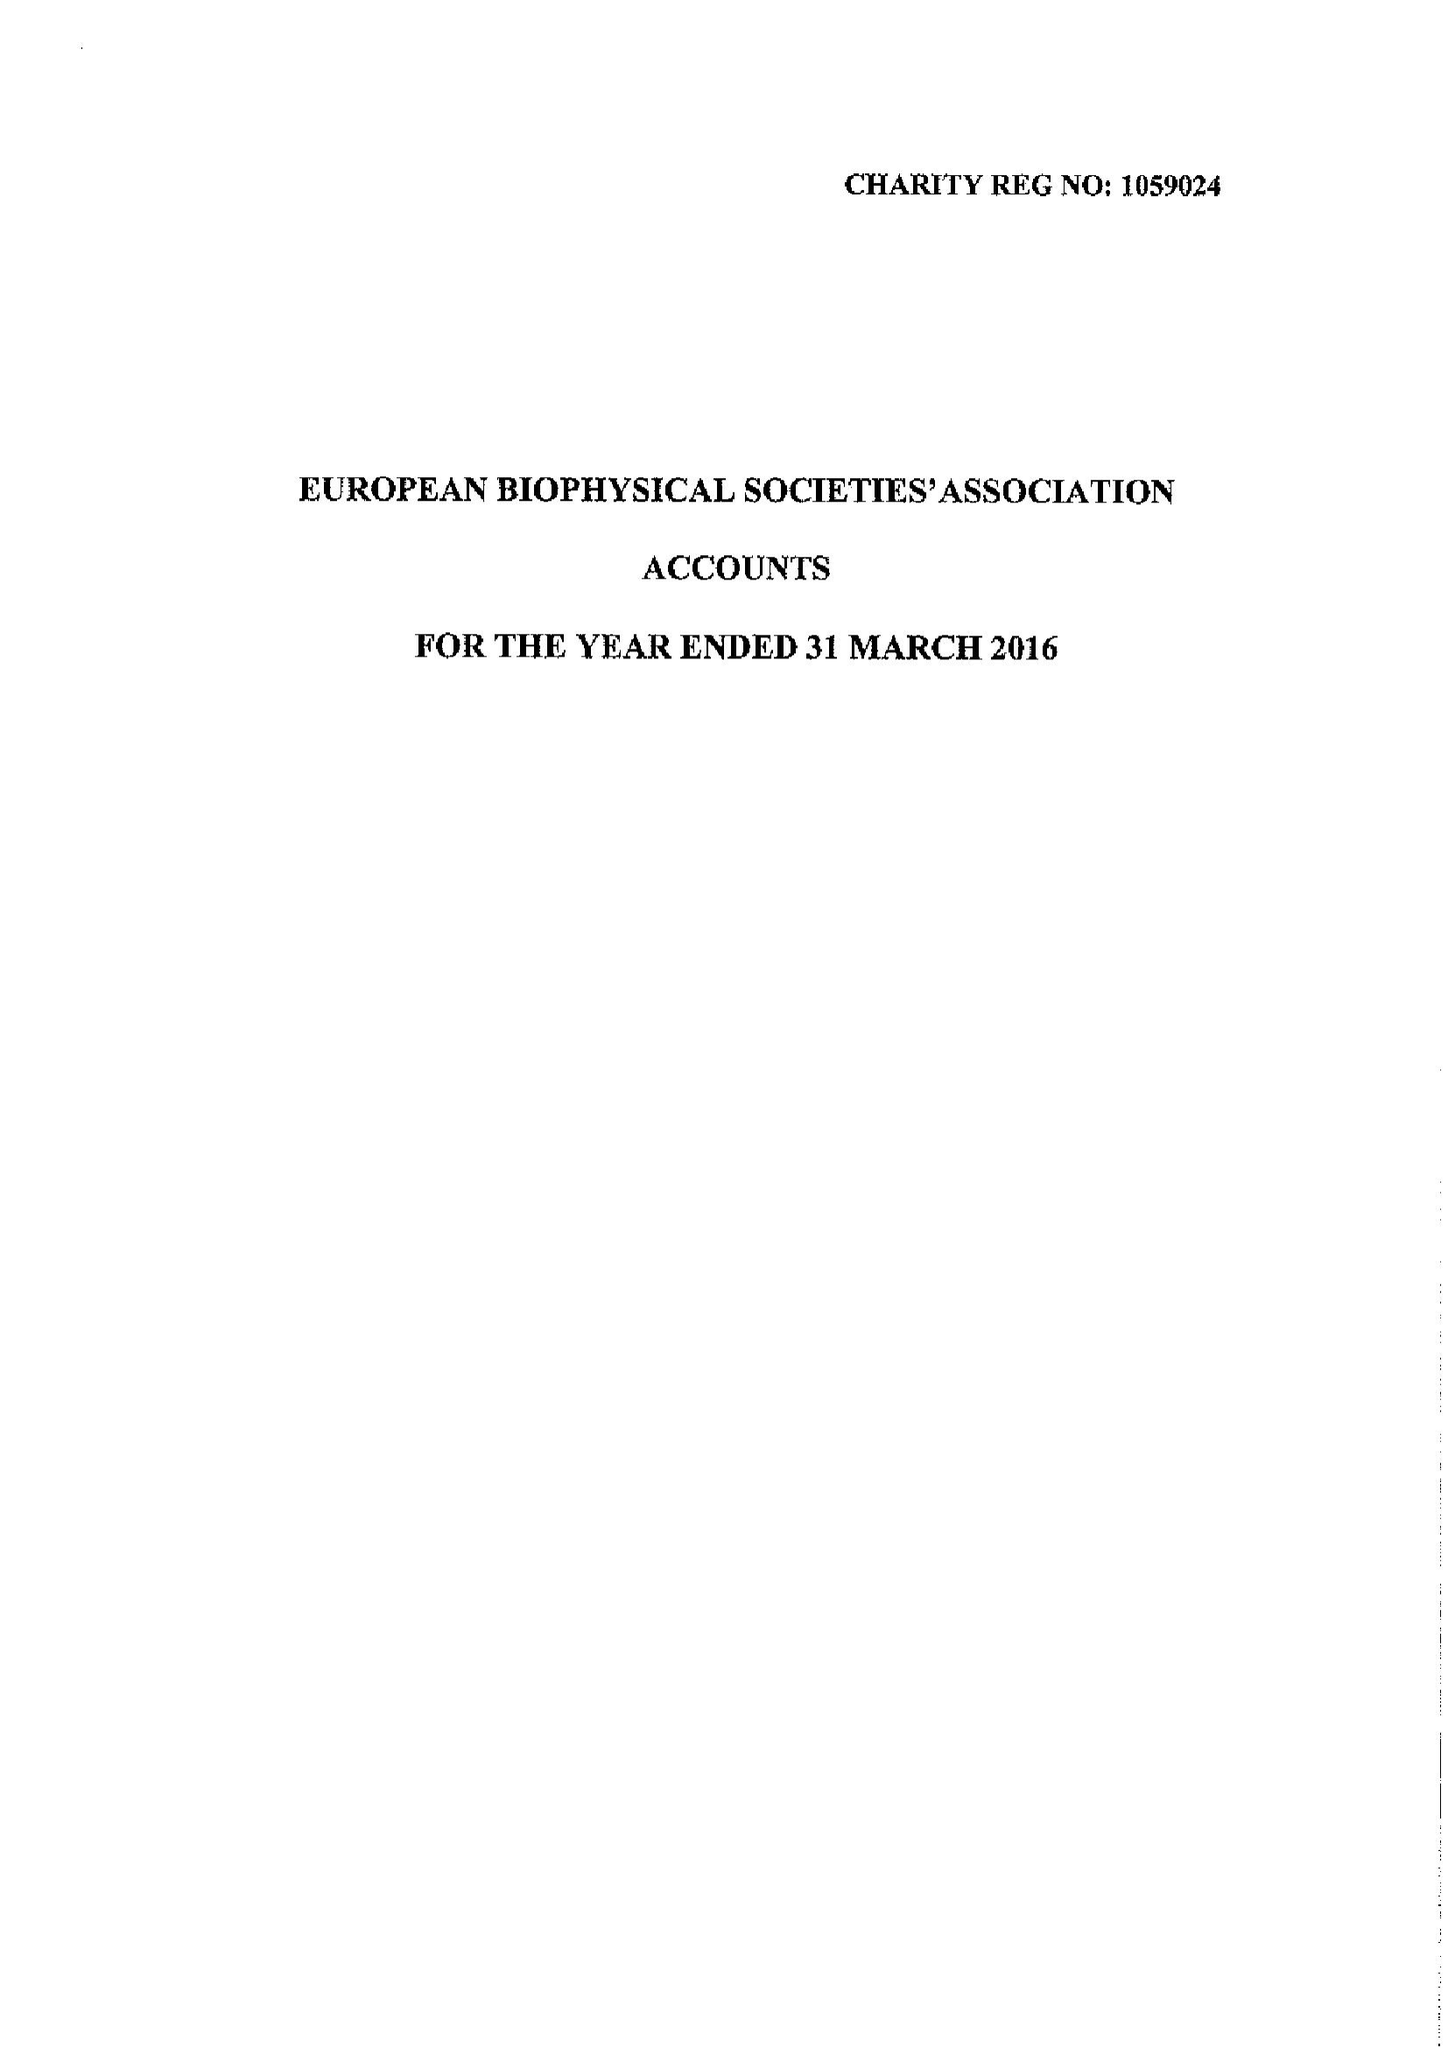What is the value for the income_annually_in_british_pounds?
Answer the question using a single word or phrase. 49570.00 